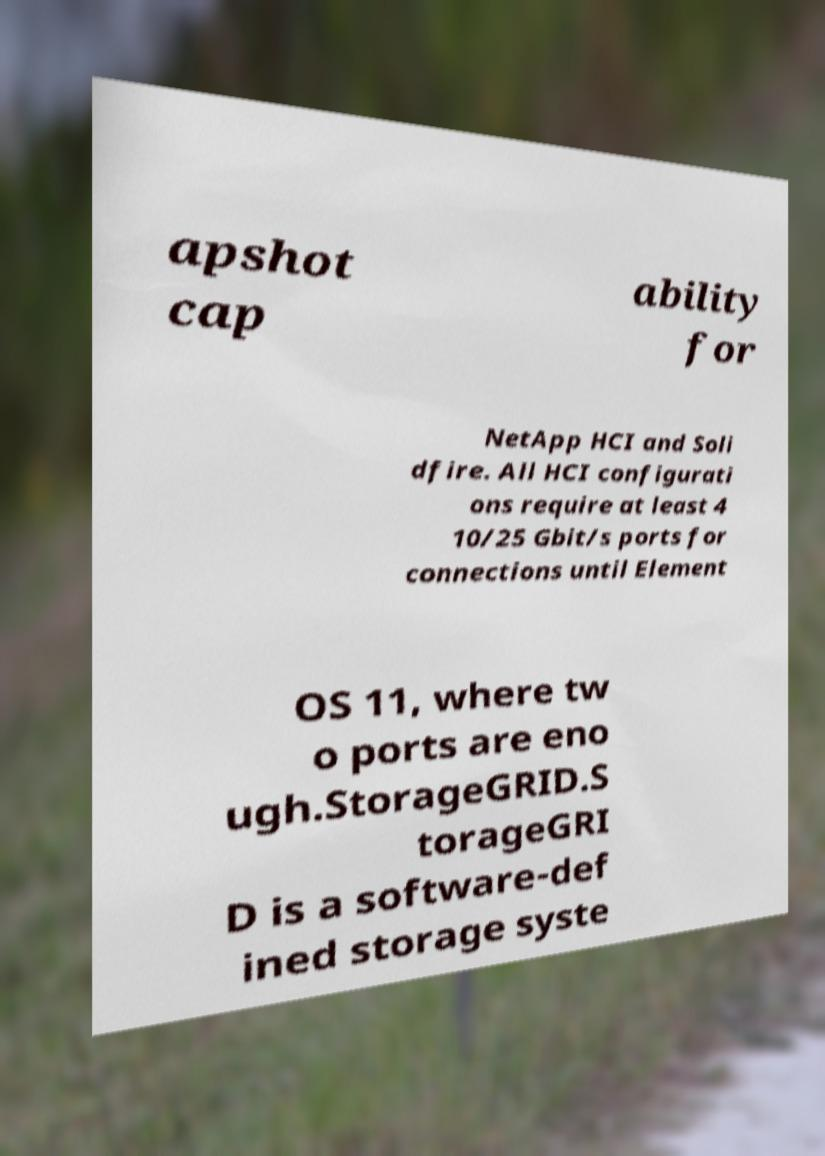Could you extract and type out the text from this image? apshot cap ability for NetApp HCI and Soli dfire. All HCI configurati ons require at least 4 10/25 Gbit/s ports for connections until Element OS 11, where tw o ports are eno ugh.StorageGRID.S torageGRI D is a software-def ined storage syste 